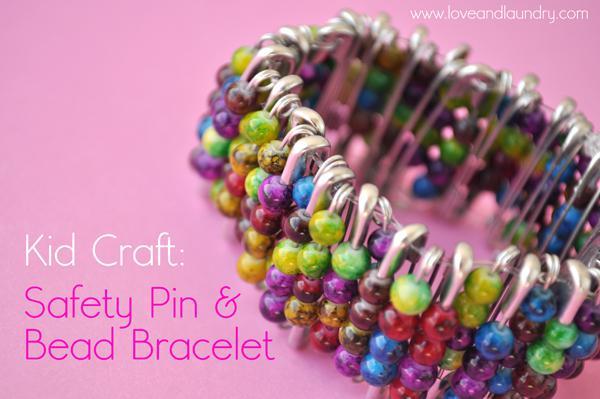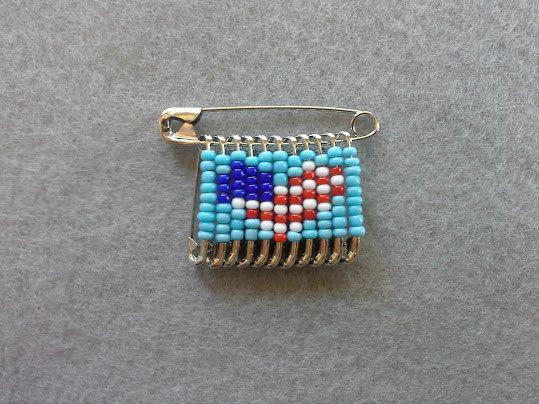The first image is the image on the left, the second image is the image on the right. For the images displayed, is the sentence "There is a heart pattern made of beads in at least one of the images." factually correct? Answer yes or no. Yes. The first image is the image on the left, the second image is the image on the right. Analyze the images presented: Is the assertion "One safety pin jewelry item features a heart design using red, white, and blue beads." valid? Answer yes or no. Yes. 